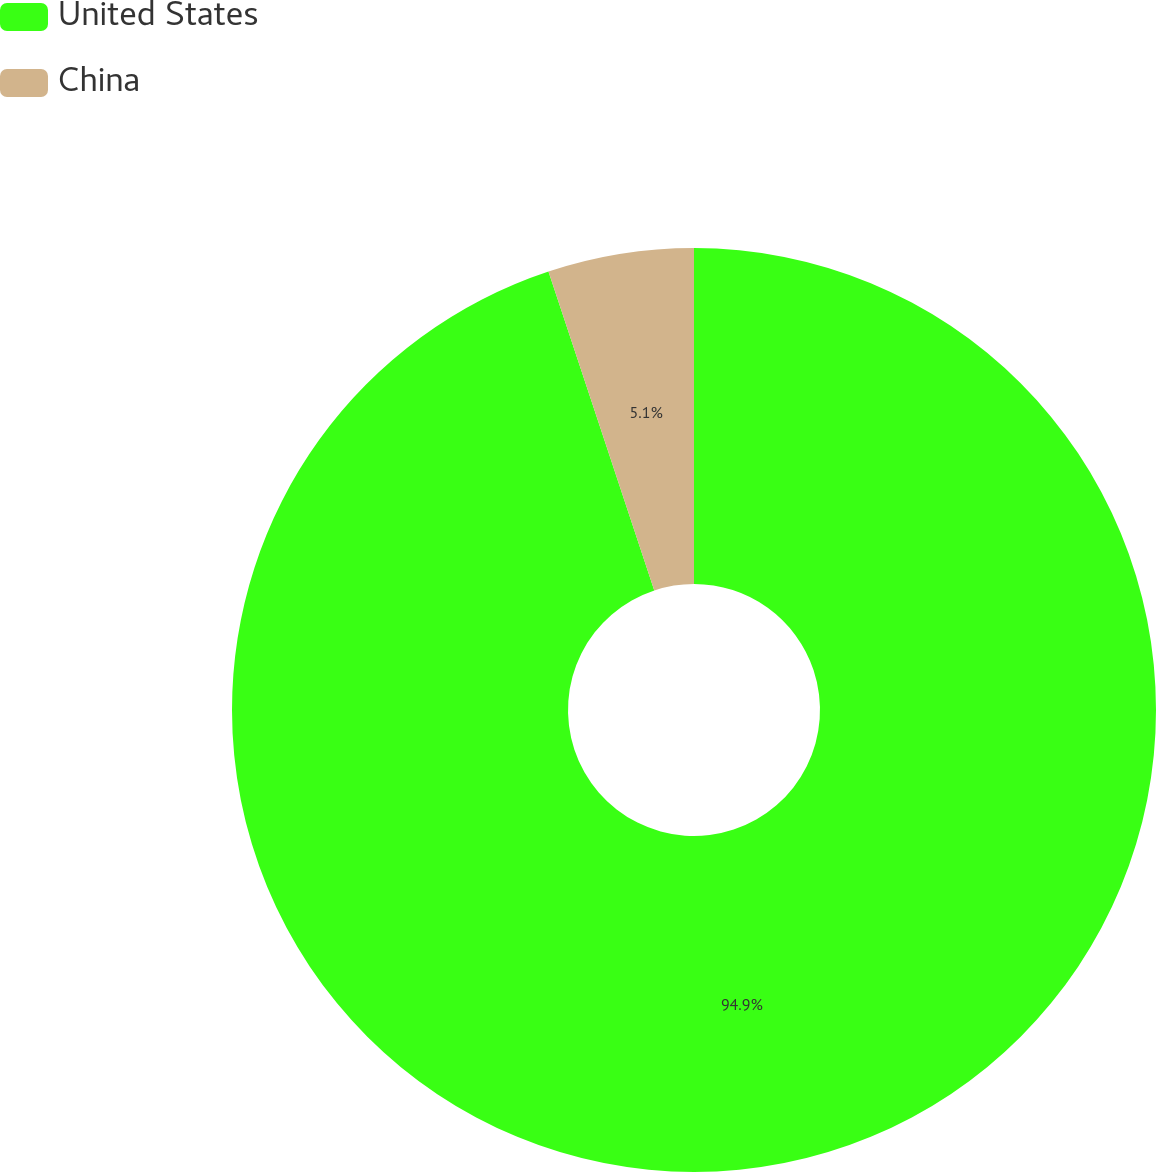Convert chart to OTSL. <chart><loc_0><loc_0><loc_500><loc_500><pie_chart><fcel>United States<fcel>China<nl><fcel>94.9%<fcel>5.1%<nl></chart> 